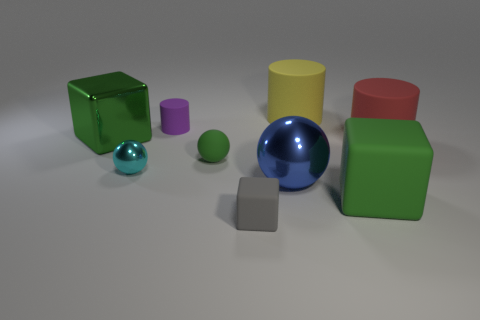Subtract all big blue metallic balls. How many balls are left? 2 Subtract all red balls. How many green blocks are left? 2 Add 1 large green cubes. How many objects exist? 10 Subtract all cylinders. How many objects are left? 6 Subtract all gray cylinders. Subtract all gray cubes. How many cylinders are left? 3 Subtract all green balls. Subtract all small cyan shiny balls. How many objects are left? 7 Add 7 large green cubes. How many large green cubes are left? 9 Add 6 large yellow rubber cylinders. How many large yellow rubber cylinders exist? 7 Subtract 0 purple balls. How many objects are left? 9 